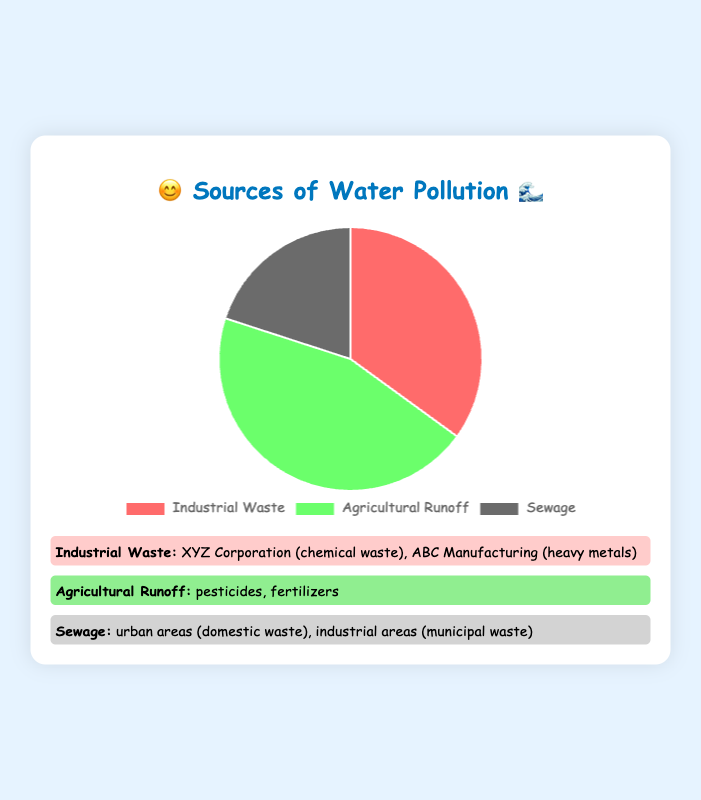what percentage of water pollution is caused by sewage? The pie chart shows that sewage is responsible for 20% of water pollution.
Answer: 20% which source causes the most water pollution? Comparing the percentages, agricultural runoff is the highest at 45%.
Answer: Agricultural Runoff how much more pollution does agricultural runoff cause compared to sewage? Agricultural runoff stands at 45%, while sewage is at 20%. The difference is 45% - 20% = 25%.
Answer: 25% which sources have examples listed alongside them in the figure? All three sources (industrial waste, agricultural runoff, and sewage) have examples provided in the figure.
Answer: Industrial Waste, Agricultural Runoff, Sewage which source causes the least water pollution? Industrial waste causes 35%, agricultural runoff 45%, and sewage 20%. The least pollution is by sewage.
Answer: Sewage what are some examples of pollutants from industrial waste? The figure lists chemical waste from XYZ Corporation and heavy metals from ABC Manufacturing.
Answer: chemical waste, heavy metals how many types of pollutants are listed under agricultural runoff? The figure indicates two types: pesticides and fertilizers.
Answer: 2 if you combine the percentages of industrial waste and sewage, what do you get? Industrial waste is 35% and sewage is 20%. Combined, they make 35% + 20% = 55%.
Answer: 55% what is the background color of the pie chart section for agricultural runoff? The pie chart indicates this section in green.
Answer: Green which source of pollution is represented by the color red in the pie chart? The pie chart shows the industrial waste section in red.
Answer: Industrial Waste 